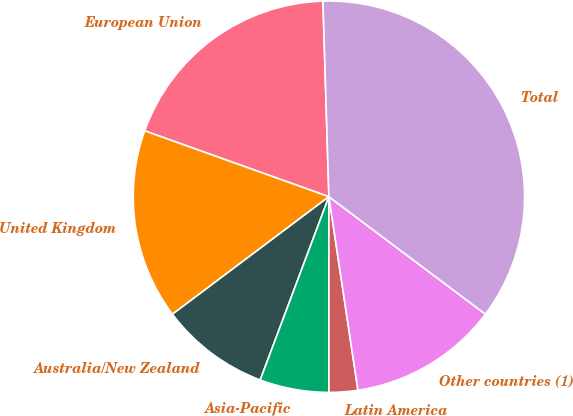<chart> <loc_0><loc_0><loc_500><loc_500><pie_chart><fcel>European Union<fcel>United Kingdom<fcel>Australia/New Zealand<fcel>Asia-Pacific<fcel>Latin America<fcel>Other countries (1)<fcel>Total<nl><fcel>19.05%<fcel>15.72%<fcel>9.04%<fcel>5.71%<fcel>2.37%<fcel>12.38%<fcel>35.73%<nl></chart> 